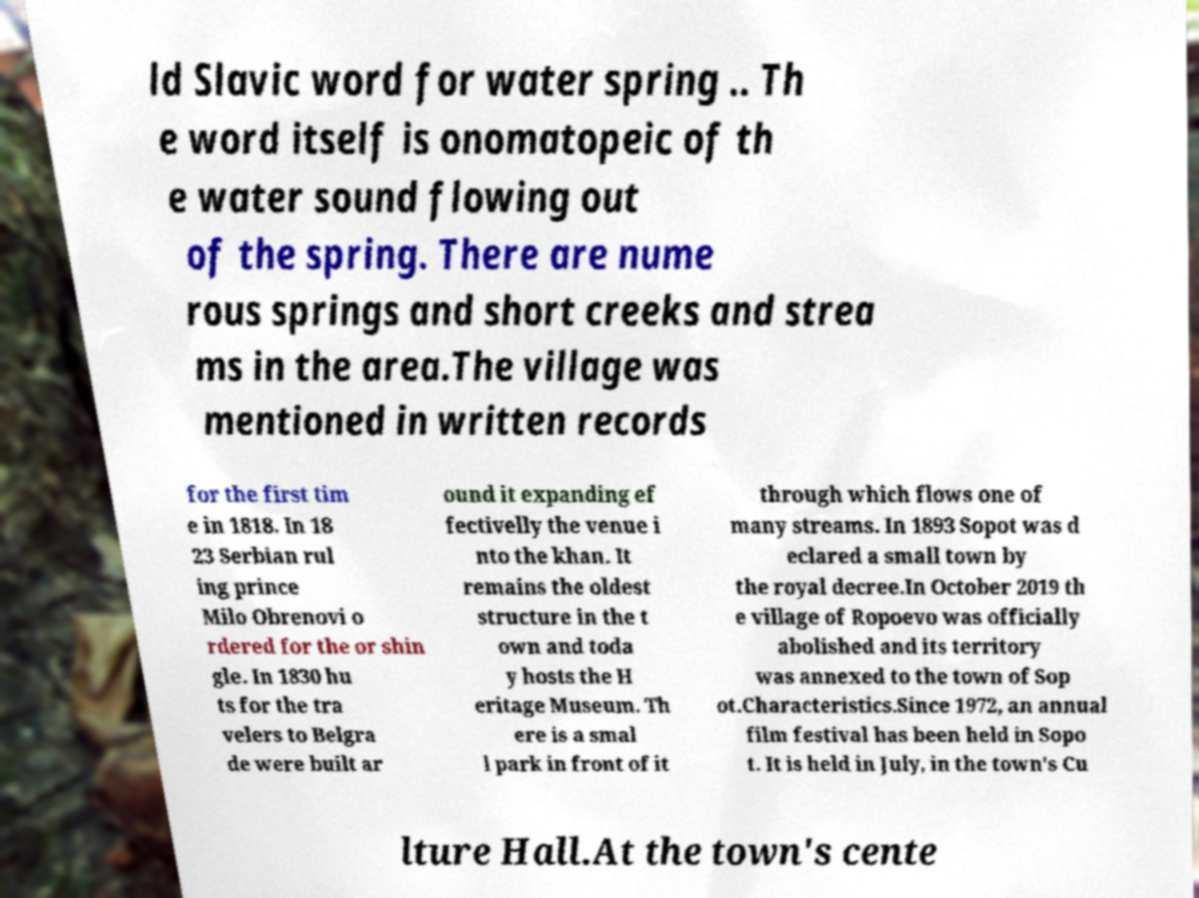Please identify and transcribe the text found in this image. ld Slavic word for water spring .. Th e word itself is onomatopeic of th e water sound flowing out of the spring. There are nume rous springs and short creeks and strea ms in the area.The village was mentioned in written records for the first tim e in 1818. In 18 23 Serbian rul ing prince Milo Obrenovi o rdered for the or shin gle. In 1830 hu ts for the tra velers to Belgra de were built ar ound it expanding ef fectivelly the venue i nto the khan. It remains the oldest structure in the t own and toda y hosts the H eritage Museum. Th ere is a smal l park in front of it through which flows one of many streams. In 1893 Sopot was d eclared a small town by the royal decree.In October 2019 th e village of Ropoevo was officially abolished and its territory was annexed to the town of Sop ot.Characteristics.Since 1972, an annual film festival has been held in Sopo t. It is held in July, in the town's Cu lture Hall.At the town's cente 